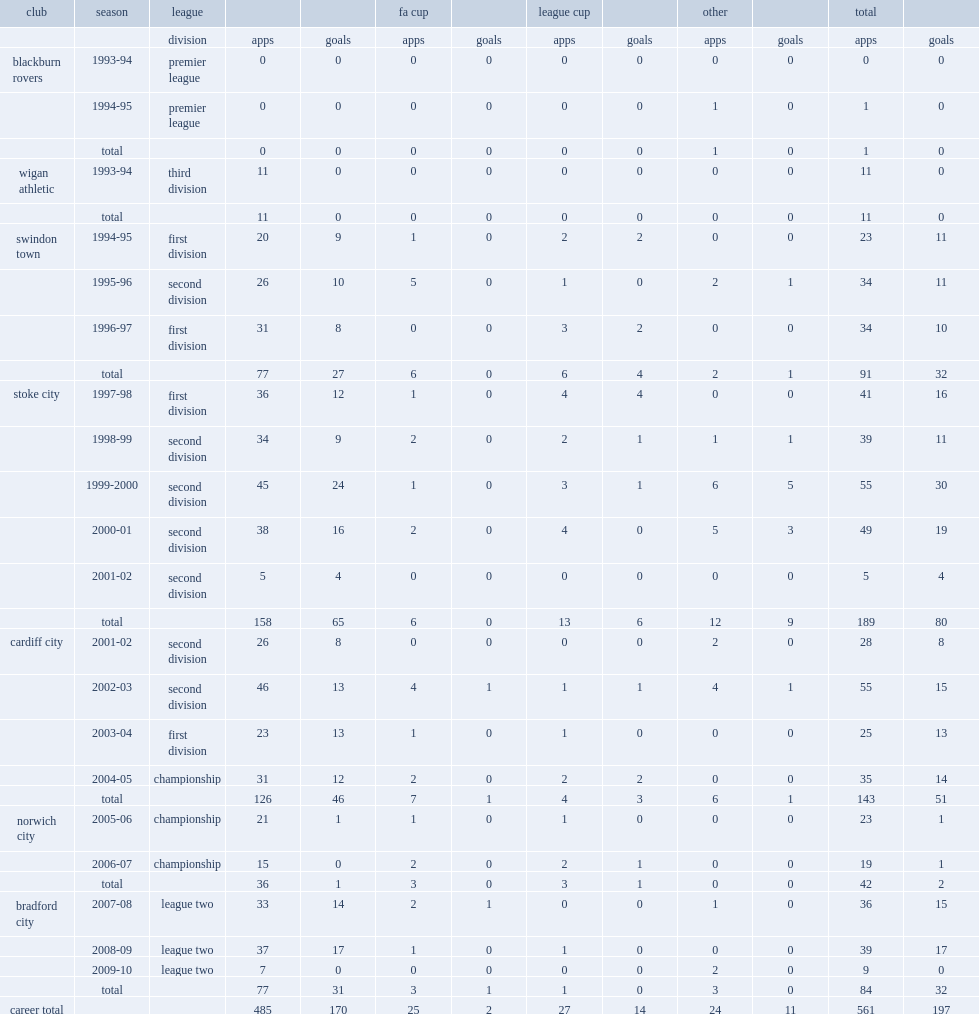How many goals did thorne score for stoke totally? 80.0. 